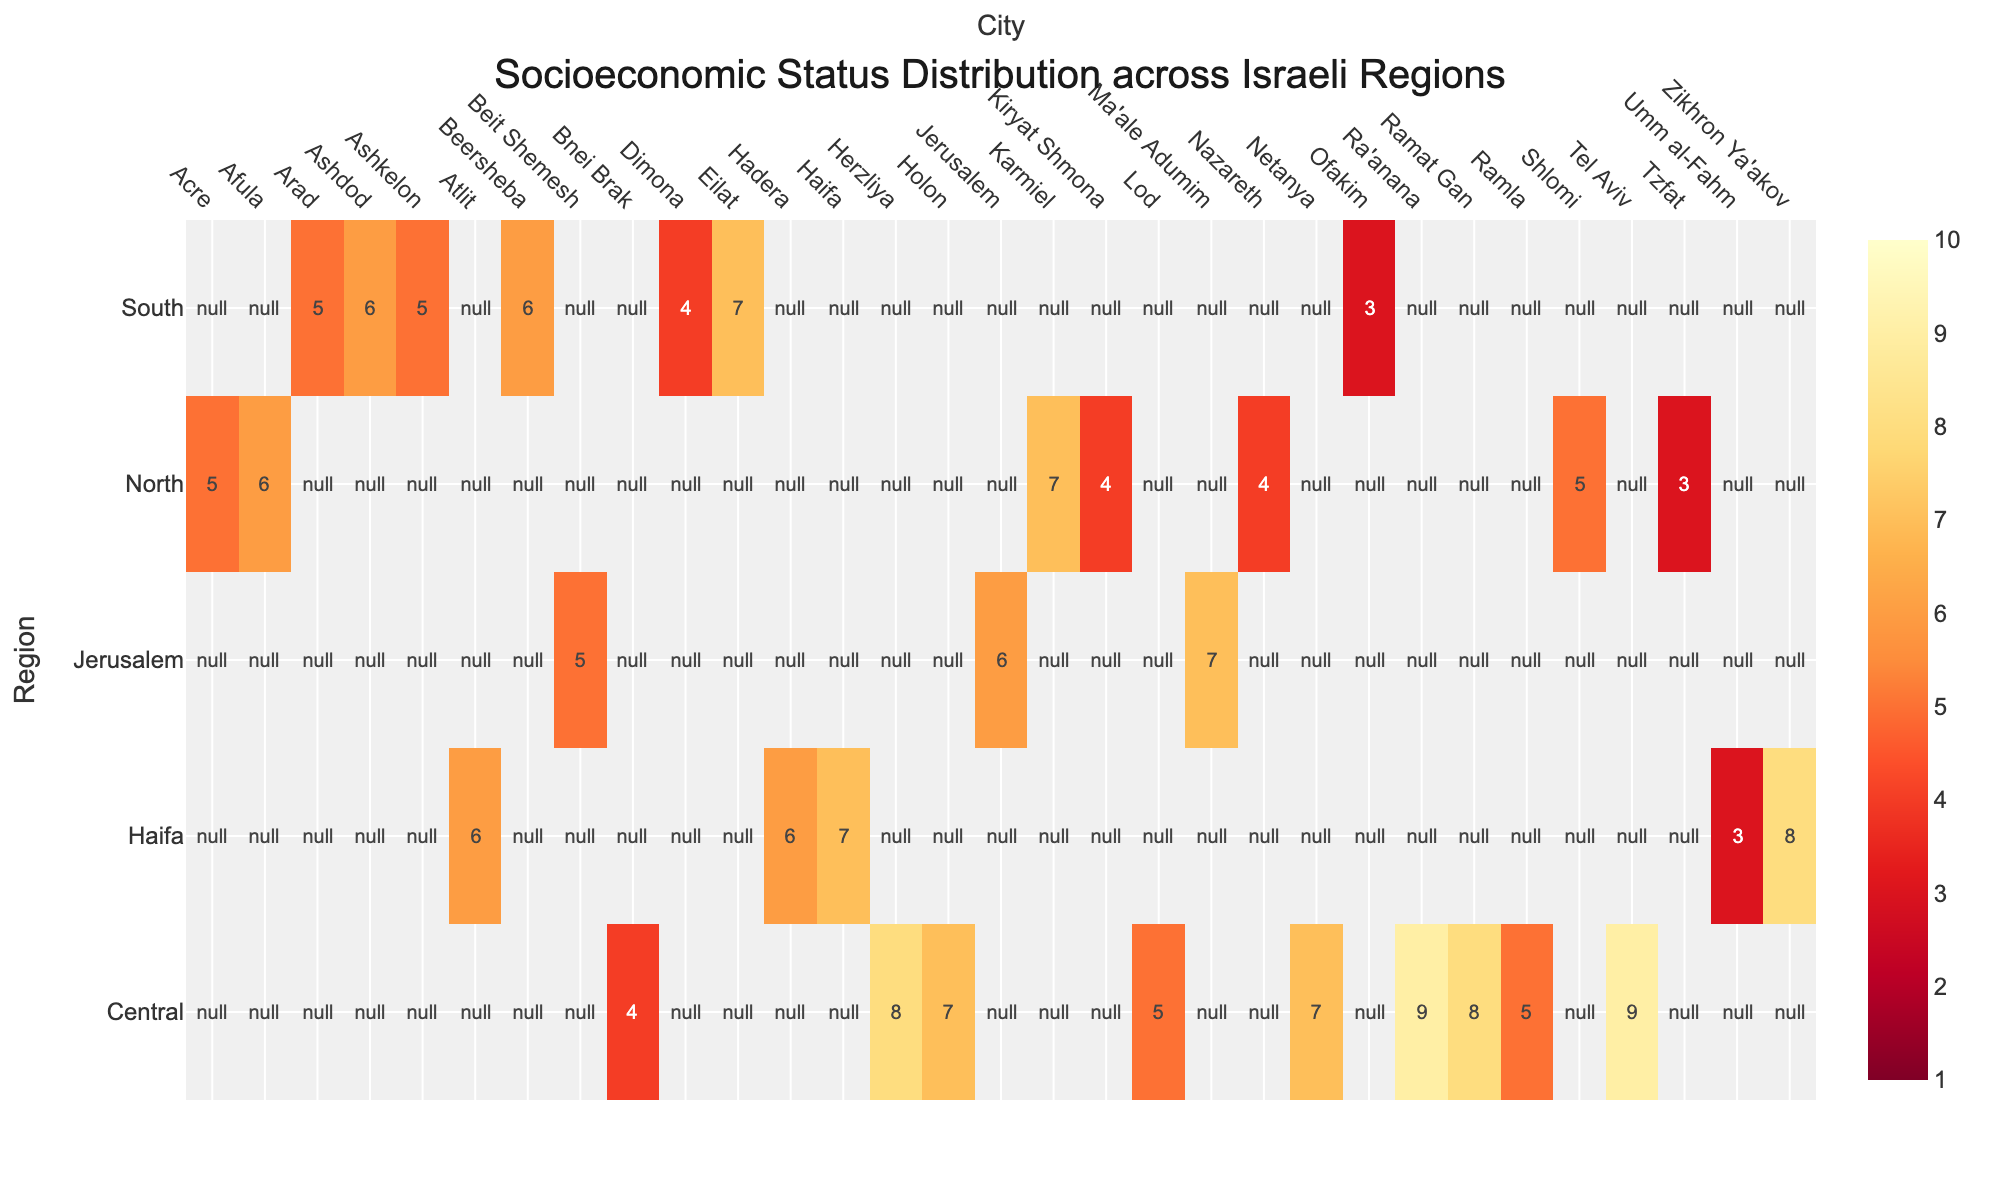Which region has the highest maximum socioeconomic status? By examining the colorscale on the heatmap and looking for the maximum value, we see that the Central region has cities with the highest socioeconomic status values.
Answer: Central Which city in the Haifa region has the lowest socioeconomic status? In the Haifa region, we look at the heatmap values under the Haifa column and identify the city with the lowest number. Umm al-Fahm is indicated with a value of 3.
Answer: Umm al-Fahm What is the average socioeconomic status for cities in the South region? To find the average, we add the socioeconomic statuses for the South region (6, 5, 6, 4, 7, 5, 3), yielding a total of 36. There are 7 cities in the South region, so we divide 36 by 7 to get an average of about 5.14.
Answer: 5.14 Which city in the Jerusalem region has a socioeconomic status of 7? By looking at the values in the Jerusalem region, we can see Ma'ale Adumim highlighted with a value of 7 on the heatmap.
Answer: Ma'ale Adumim Compare the socioeconomic status between Haifa and Tel Aviv. Which is higher? Using the heatmap, we see that Haifa has a value of 7 and Tel Aviv has a value of 9. Therefore, Tel Aviv has a higher socioeconomic status.
Answer: Tel Aviv What is the difference in socioeconomic status between Acre and Kiryat Shmona? From the heatmap, Acre has a socioeconomic status of 5 and Kiryat Shmona has a value of 4. The difference is 5 - 4 = 1.
Answer: 1 Which region contains the most cities with a socioeconomic status of 5? By counting the number of occurrences of '5' in each region, we find that the Central and South regions both have two cities with a socioeconomic status of 5.
Answer: Central and South Is there a city in the North region with a socioeconomic status higher than any city in the Jerusalem region? By comparing the highest value in the North (Karmiel, 7) with the highest in Jerusalem (Ma'ale Adumim, 7), we see no city in the North surpasses the value in Jerusalem.
Answer: No 